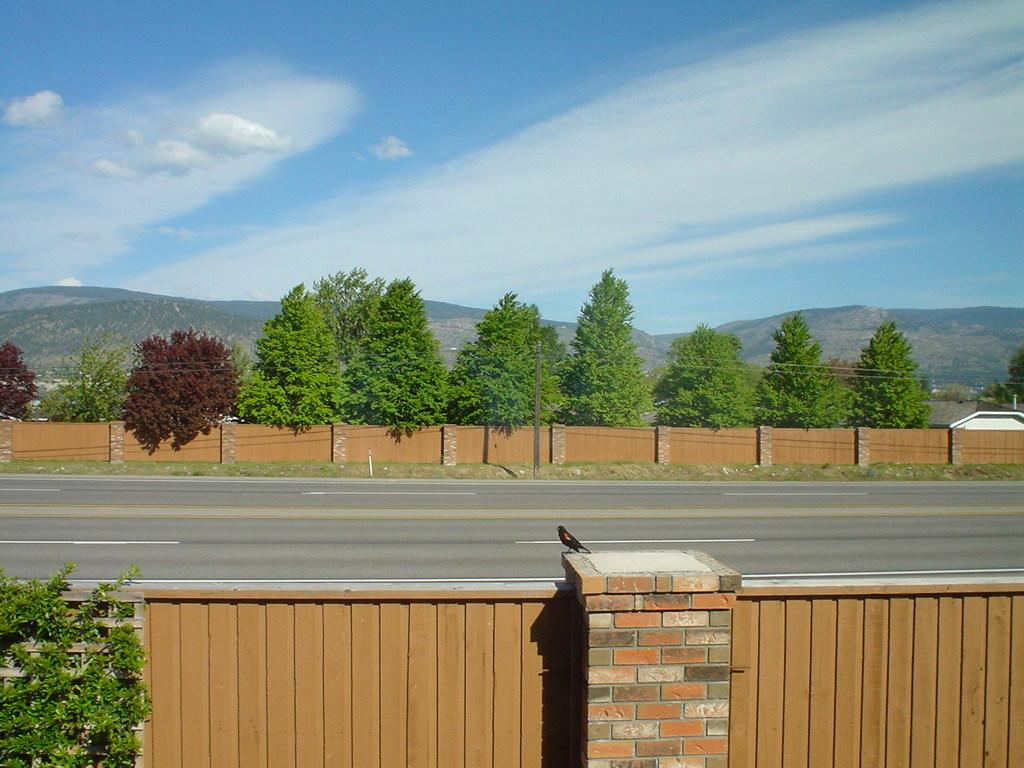What is located at the bottom of the image? There is a bird on the wall at the bottom of the image. What can be seen in the background of the image? There are trees, hills, a fence, and the sky visible in the background of the image. What type of cactus can be seen playing with the bird in the image? There is no cactus or indication of play in the image; it features a bird on a wall with a background of trees, hills, a fence, and the sky. 